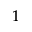Convert formula to latex. <formula><loc_0><loc_0><loc_500><loc_500>_ { 1 }</formula> 